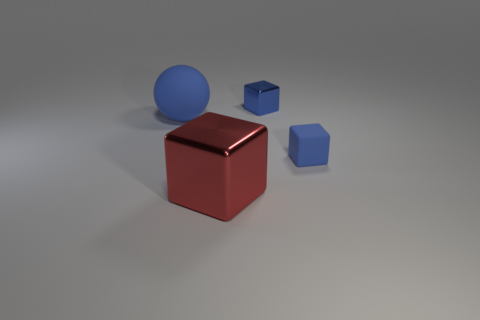Add 1 big red objects. How many objects exist? 5 Subtract all spheres. How many objects are left? 3 Subtract all blue matte spheres. Subtract all balls. How many objects are left? 2 Add 1 rubber objects. How many rubber objects are left? 3 Add 1 red metallic cubes. How many red metallic cubes exist? 2 Subtract 0 gray spheres. How many objects are left? 4 